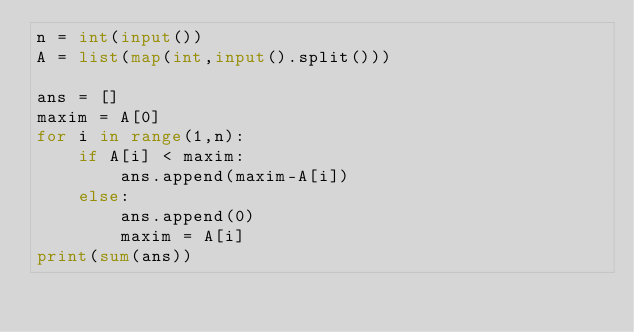<code> <loc_0><loc_0><loc_500><loc_500><_Python_>n = int(input())
A = list(map(int,input().split()))

ans = []
maxim = A[0]
for i in range(1,n):
    if A[i] < maxim:
        ans.append(maxim-A[i])
    else:
        ans.append(0)
        maxim = A[i]
print(sum(ans))</code> 